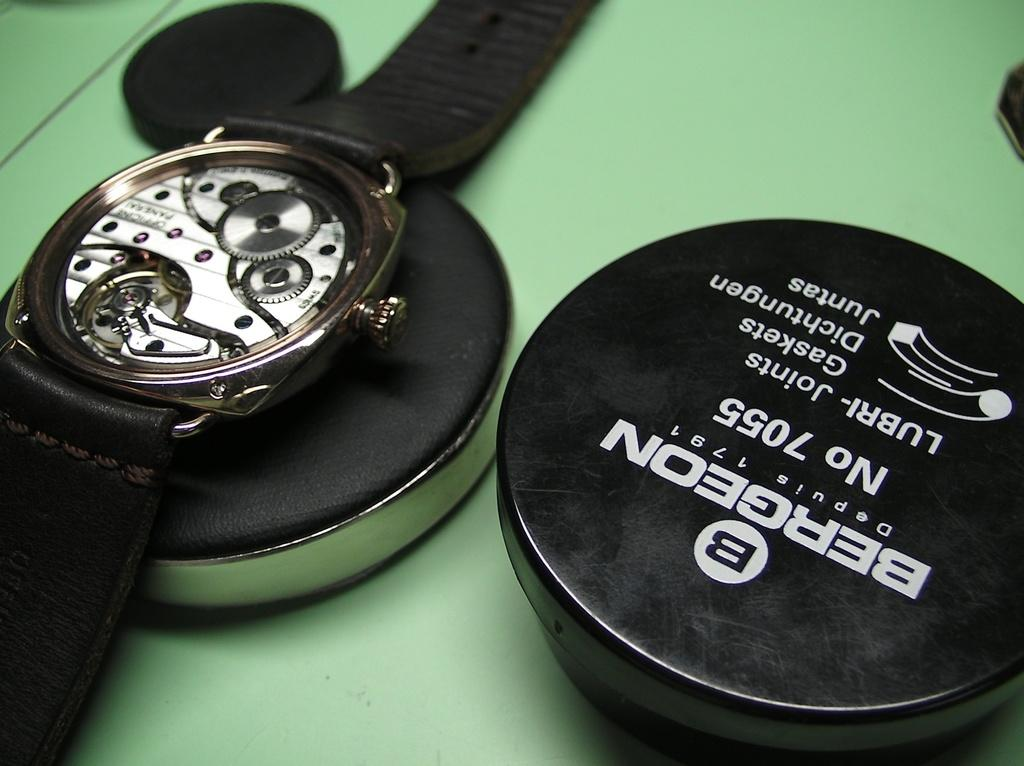<image>
Write a terse but informative summary of the picture. A round thing that says Bergeon No 7055 on it. 